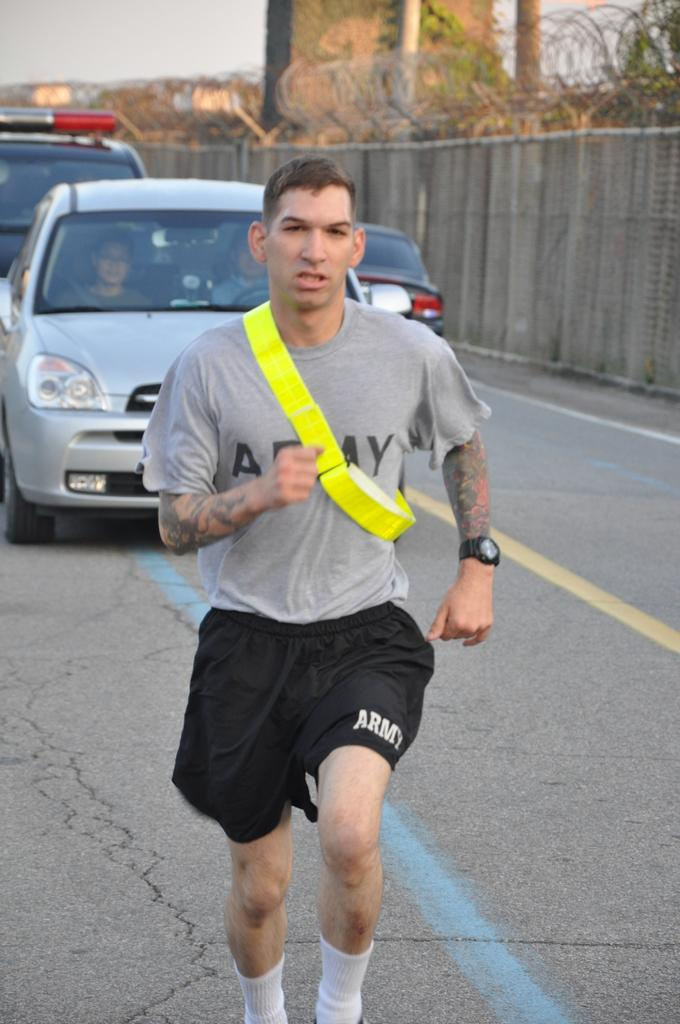What is the man in the image doing? The man is running on the road. What else can be seen on the road in the image? Motor vehicles are present on the road. What is along the wall in the image? There are fences along the wall. What type of vegetation is visible in the image? Creepers are visible. What is visible in the background of the image? The sky is visible in the image. What type of balance does the turkey have in the image? There is no turkey present in the image, so it is not possible to determine its balance. 